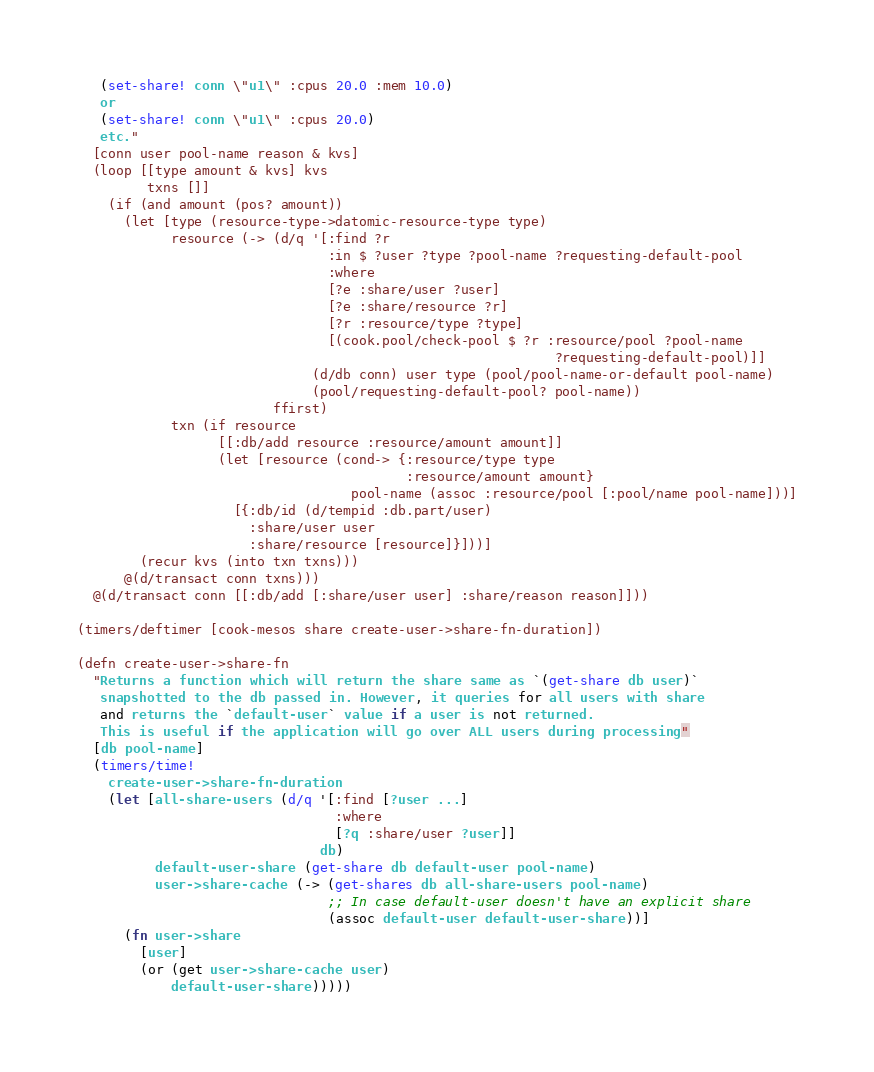Convert code to text. <code><loc_0><loc_0><loc_500><loc_500><_Clojure_>   (set-share! conn \"u1\" :cpus 20.0 :mem 10.0)
   or
   (set-share! conn \"u1\" :cpus 20.0)
   etc."
  [conn user pool-name reason & kvs]
  (loop [[type amount & kvs] kvs
         txns []]
    (if (and amount (pos? amount))
      (let [type (resource-type->datomic-resource-type type)
            resource (-> (d/q '[:find ?r
                                :in $ ?user ?type ?pool-name ?requesting-default-pool
                                :where
                                [?e :share/user ?user]
                                [?e :share/resource ?r]
                                [?r :resource/type ?type]
                                [(cook.pool/check-pool $ ?r :resource/pool ?pool-name
                                                             ?requesting-default-pool)]]
                              (d/db conn) user type (pool/pool-name-or-default pool-name)
                              (pool/requesting-default-pool? pool-name))
                         ffirst)
            txn (if resource
                  [[:db/add resource :resource/amount amount]]
                  (let [resource (cond-> {:resource/type type
                                          :resource/amount amount}
                                   pool-name (assoc :resource/pool [:pool/name pool-name]))]
                    [{:db/id (d/tempid :db.part/user)
                      :share/user user
                      :share/resource [resource]}]))]
        (recur kvs (into txn txns)))
      @(d/transact conn txns)))
  @(d/transact conn [[:db/add [:share/user user] :share/reason reason]]))

(timers/deftimer [cook-mesos share create-user->share-fn-duration])

(defn create-user->share-fn
  "Returns a function which will return the share same as `(get-share db user)`
   snapshotted to the db passed in. However, it queries for all users with share
   and returns the `default-user` value if a user is not returned.
   This is useful if the application will go over ALL users during processing"
  [db pool-name]
  (timers/time!
    create-user->share-fn-duration
    (let [all-share-users (d/q '[:find [?user ...]
                                 :where
                                 [?q :share/user ?user]]
                               db)
          default-user-share (get-share db default-user pool-name)
          user->share-cache (-> (get-shares db all-share-users pool-name)
                                ;; In case default-user doesn't have an explicit share
                                (assoc default-user default-user-share))]
      (fn user->share
        [user]
        (or (get user->share-cache user)
            default-user-share)))))
</code> 